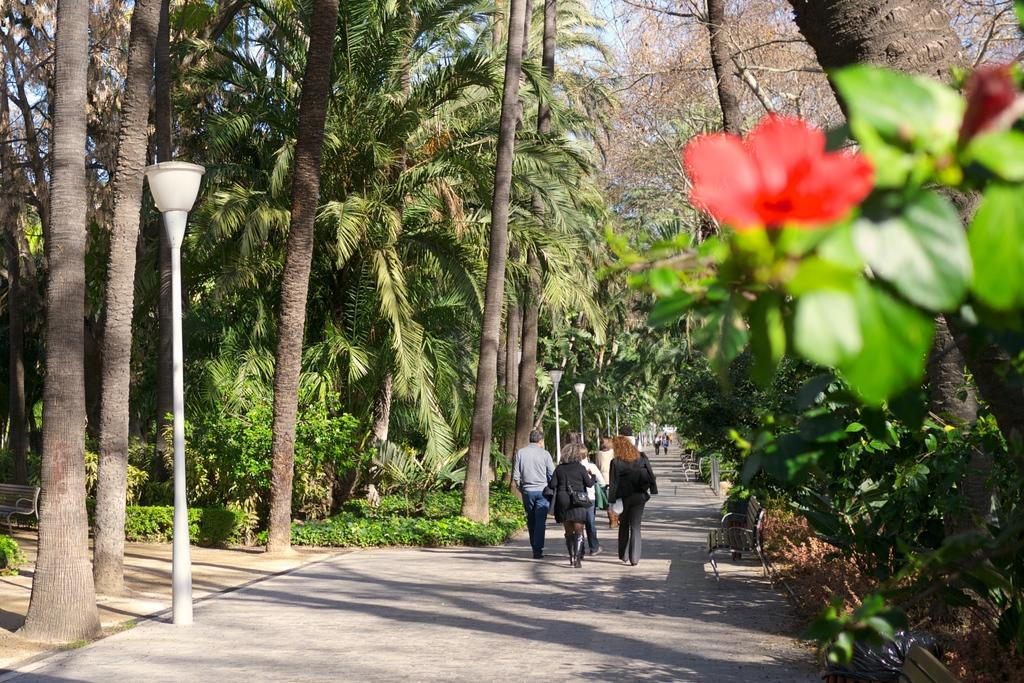What type of vegetation can be seen in the image? There are trees in the image. What type of lighting is present in the image? There are pole lights in the image. What are the people in the image doing? There are people walking in the image. What type of flora is present in the image? There are flowers in the image. What type of seating is available in the image? There are benches in the image. What color is the sky in the image? The sky is blue in the image. Can you see a patch of grass on the hat of one of the people walking in the image? There is no hat or patch of grass on a hat visible in the image. How do the people in the image join together to form a single entity? The people in the image are not joining together to form a single entity; they are walking separately. 